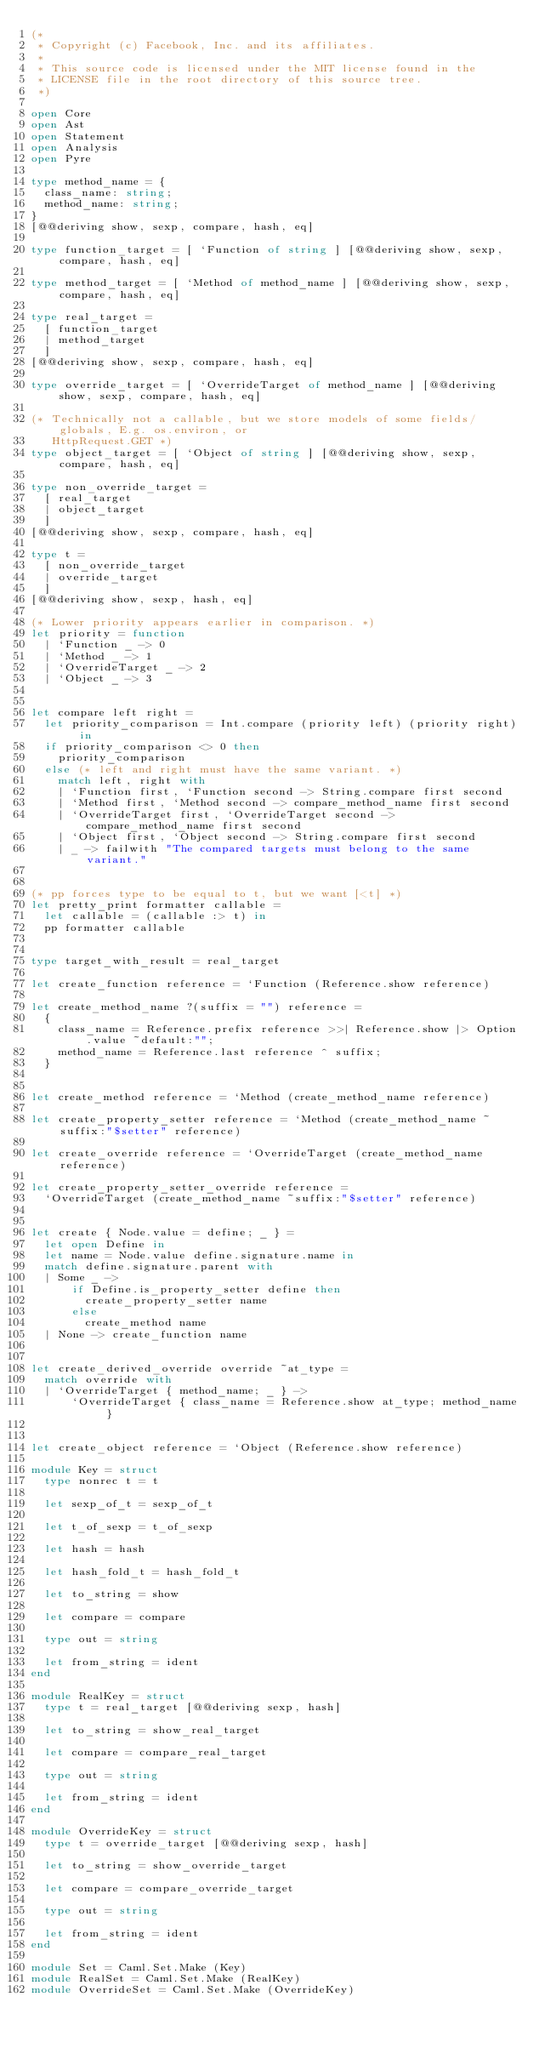<code> <loc_0><loc_0><loc_500><loc_500><_OCaml_>(*
 * Copyright (c) Facebook, Inc. and its affiliates.
 *
 * This source code is licensed under the MIT license found in the
 * LICENSE file in the root directory of this source tree.
 *)

open Core
open Ast
open Statement
open Analysis
open Pyre

type method_name = {
  class_name: string;
  method_name: string;
}
[@@deriving show, sexp, compare, hash, eq]

type function_target = [ `Function of string ] [@@deriving show, sexp, compare, hash, eq]

type method_target = [ `Method of method_name ] [@@deriving show, sexp, compare, hash, eq]

type real_target =
  [ function_target
  | method_target
  ]
[@@deriving show, sexp, compare, hash, eq]

type override_target = [ `OverrideTarget of method_name ] [@@deriving show, sexp, compare, hash, eq]

(* Technically not a callable, but we store models of some fields/globals, E.g. os.environ, or
   HttpRequest.GET *)
type object_target = [ `Object of string ] [@@deriving show, sexp, compare, hash, eq]

type non_override_target =
  [ real_target
  | object_target
  ]
[@@deriving show, sexp, compare, hash, eq]

type t =
  [ non_override_target
  | override_target
  ]
[@@deriving show, sexp, hash, eq]

(* Lower priority appears earlier in comparison. *)
let priority = function
  | `Function _ -> 0
  | `Method _ -> 1
  | `OverrideTarget _ -> 2
  | `Object _ -> 3


let compare left right =
  let priority_comparison = Int.compare (priority left) (priority right) in
  if priority_comparison <> 0 then
    priority_comparison
  else (* left and right must have the same variant. *)
    match left, right with
    | `Function first, `Function second -> String.compare first second
    | `Method first, `Method second -> compare_method_name first second
    | `OverrideTarget first, `OverrideTarget second -> compare_method_name first second
    | `Object first, `Object second -> String.compare first second
    | _ -> failwith "The compared targets must belong to the same variant."


(* pp forces type to be equal to t, but we want [<t] *)
let pretty_print formatter callable =
  let callable = (callable :> t) in
  pp formatter callable


type target_with_result = real_target

let create_function reference = `Function (Reference.show reference)

let create_method_name ?(suffix = "") reference =
  {
    class_name = Reference.prefix reference >>| Reference.show |> Option.value ~default:"";
    method_name = Reference.last reference ^ suffix;
  }


let create_method reference = `Method (create_method_name reference)

let create_property_setter reference = `Method (create_method_name ~suffix:"$setter" reference)

let create_override reference = `OverrideTarget (create_method_name reference)

let create_property_setter_override reference =
  `OverrideTarget (create_method_name ~suffix:"$setter" reference)


let create { Node.value = define; _ } =
  let open Define in
  let name = Node.value define.signature.name in
  match define.signature.parent with
  | Some _ ->
      if Define.is_property_setter define then
        create_property_setter name
      else
        create_method name
  | None -> create_function name


let create_derived_override override ~at_type =
  match override with
  | `OverrideTarget { method_name; _ } ->
      `OverrideTarget { class_name = Reference.show at_type; method_name }


let create_object reference = `Object (Reference.show reference)

module Key = struct
  type nonrec t = t

  let sexp_of_t = sexp_of_t

  let t_of_sexp = t_of_sexp

  let hash = hash

  let hash_fold_t = hash_fold_t

  let to_string = show

  let compare = compare

  type out = string

  let from_string = ident
end

module RealKey = struct
  type t = real_target [@@deriving sexp, hash]

  let to_string = show_real_target

  let compare = compare_real_target

  type out = string

  let from_string = ident
end

module OverrideKey = struct
  type t = override_target [@@deriving sexp, hash]

  let to_string = show_override_target

  let compare = compare_override_target

  type out = string

  let from_string = ident
end

module Set = Caml.Set.Make (Key)
module RealSet = Caml.Set.Make (RealKey)
module OverrideSet = Caml.Set.Make (OverrideKey)
</code> 